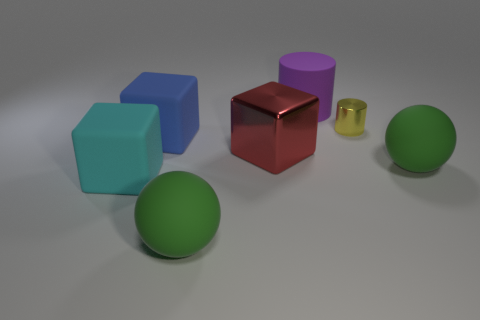Is there anything else that has the same size as the yellow cylinder?
Your answer should be compact. No. There is a small thing that is to the right of the large cyan cube; is its color the same as the big matte ball on the left side of the shiny block?
Your answer should be very brief. No. There is a big metallic cube; what number of large blue things are in front of it?
Your response must be concise. 0. Are there any tiny red matte objects of the same shape as the blue thing?
Give a very brief answer. No. There is another matte block that is the same size as the blue block; what is its color?
Ensure brevity in your answer.  Cyan. Is the number of large rubber objects in front of the tiny yellow metal thing less than the number of red metal things that are on the left side of the red shiny block?
Make the answer very short. No. There is a ball that is in front of the cyan matte object; is its size the same as the yellow object?
Give a very brief answer. No. There is a tiny yellow object that is behind the big red object; what shape is it?
Offer a terse response. Cylinder. Is the number of big purple cylinders greater than the number of large green spheres?
Provide a short and direct response. No. There is a shiny object that is to the right of the metallic cube; does it have the same color as the matte cylinder?
Keep it short and to the point. No. 